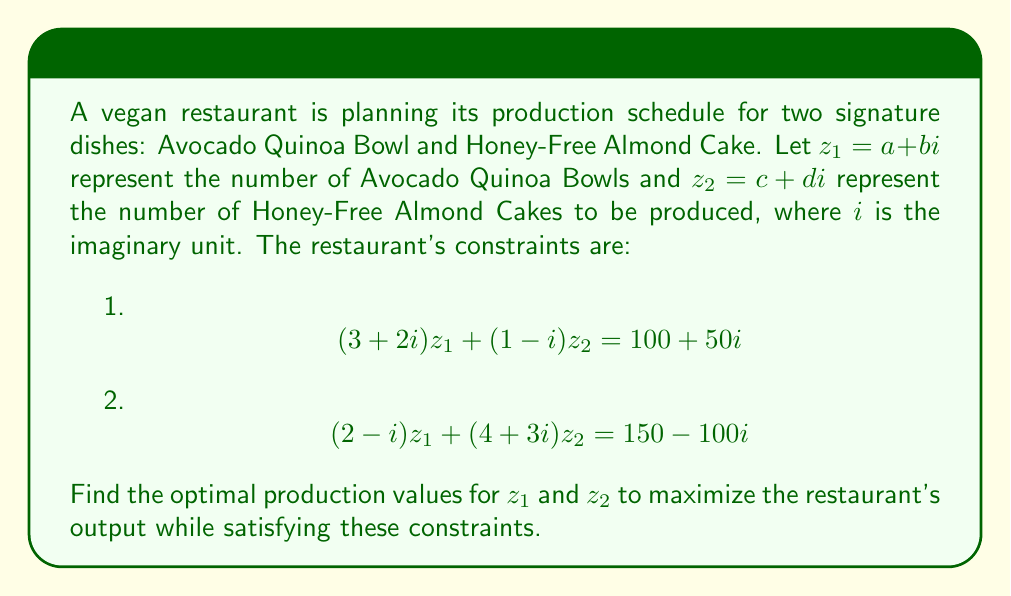Can you solve this math problem? To solve this system of equations with complex numbers, we'll use the following steps:

1) First, let's separate the real and imaginary parts of each equation:

   Equation 1: $(3+2i)(a+bi) + (1-i)(c+di) = 100 + 50i$
   Equation 2: $(2-i)(a+bi) + (4+3i)(c+di) = 150 - 100i$

2) Expand these equations:

   Eq. 1: $(3a-2b+2a+3b) + (c-d+d-c)i = 100 + 50i$
   Eq. 2: $(2a+b-a+2b) + (4c-3d+3c+4d)i = 150 - 100i$

3) Simplify:

   Eq. 1: $(3a-2b+2a+3b) + (0)i = 100 + 50i$
   Eq. 2: $(2a+b-a+2b) + (4c-3d+3c+4d)i = 150 - 100i$

4) Equate real and imaginary parts:

   From Eq. 1:
   $5a + b = 100$
   $0 = 50$

   From Eq. 2:
   $a + 3b = 150$
   $7c + d = -100$

5) We now have a system of linear equations:

   $5a + b = 100$
   $a + 3b = 150$
   $7c + d = -100$

6) Solve for $a$ and $b$ using substitution:

   From $5a + b = 100$, we get $b = 100 - 5a$
   Substituting into $a + 3b = 150$:
   $a + 3(100 - 5a) = 150$
   $a + 300 - 15a = 150$
   $-14a = -150$
   $a = \frac{150}{14} = \frac{75}{7}$

   Substitute back to find $b$:
   $b = 100 - 5(\frac{75}{7}) = 100 - \frac{375}{7} = \frac{325}{7}$

7) For $c$ and $d$, we only have one equation: $7c + d = -100$
   This means we have infinitely many solutions. Let's express $d$ in terms of $c$:
   $d = -100 - 7c$

8) Therefore, our solutions are:

   $z_1 = a + bi = \frac{75}{7} + \frac{325}{7}i$
   $z_2 = c + di = c + (-100 - 7c)i$, where $c$ is a free variable.
Answer: $z_1 = \frac{75}{7} + \frac{325}{7}i$, $z_2 = c + (-100 - 7c)i$ where $c$ is a free variable 